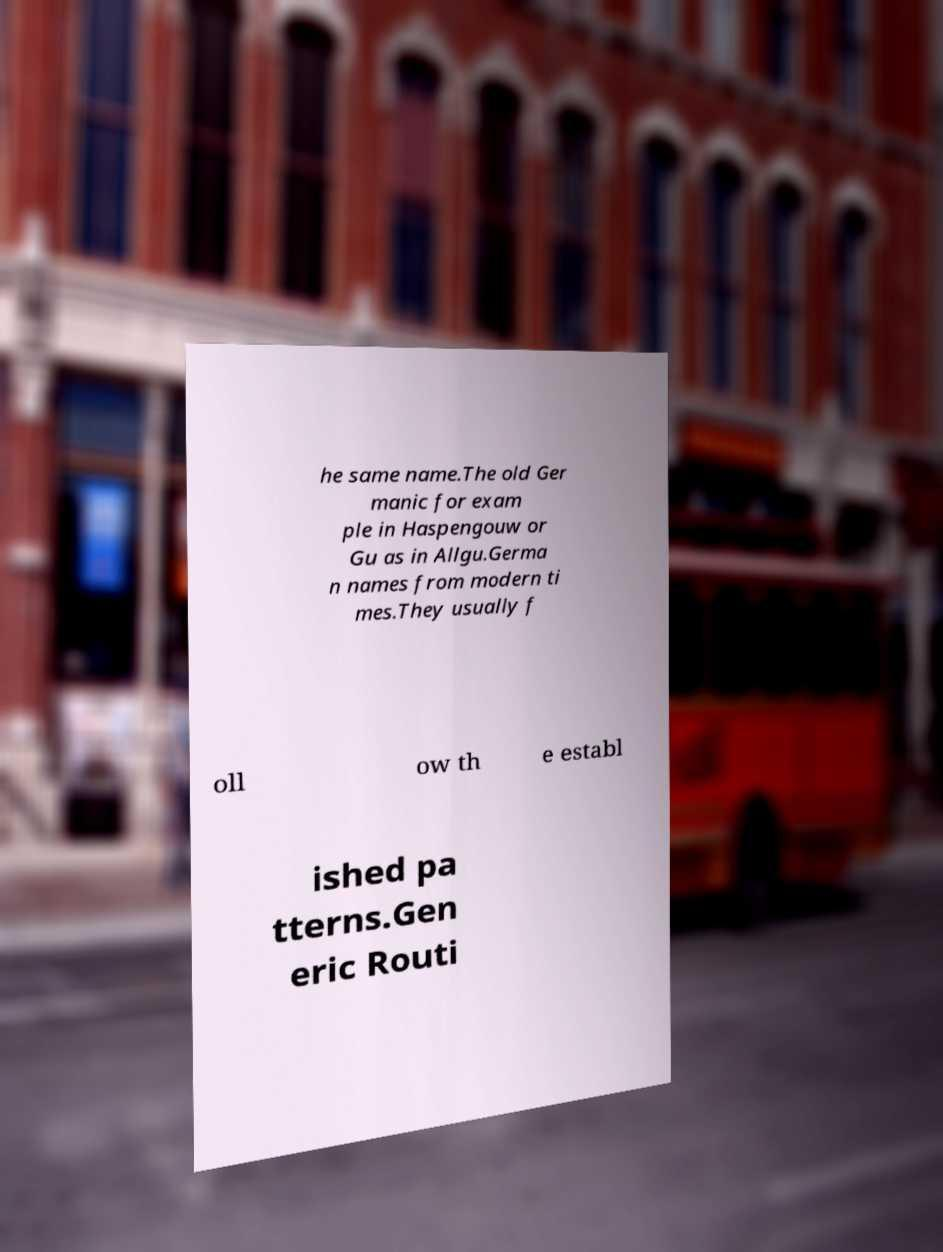I need the written content from this picture converted into text. Can you do that? he same name.The old Ger manic for exam ple in Haspengouw or Gu as in Allgu.Germa n names from modern ti mes.They usually f oll ow th e establ ished pa tterns.Gen eric Routi 